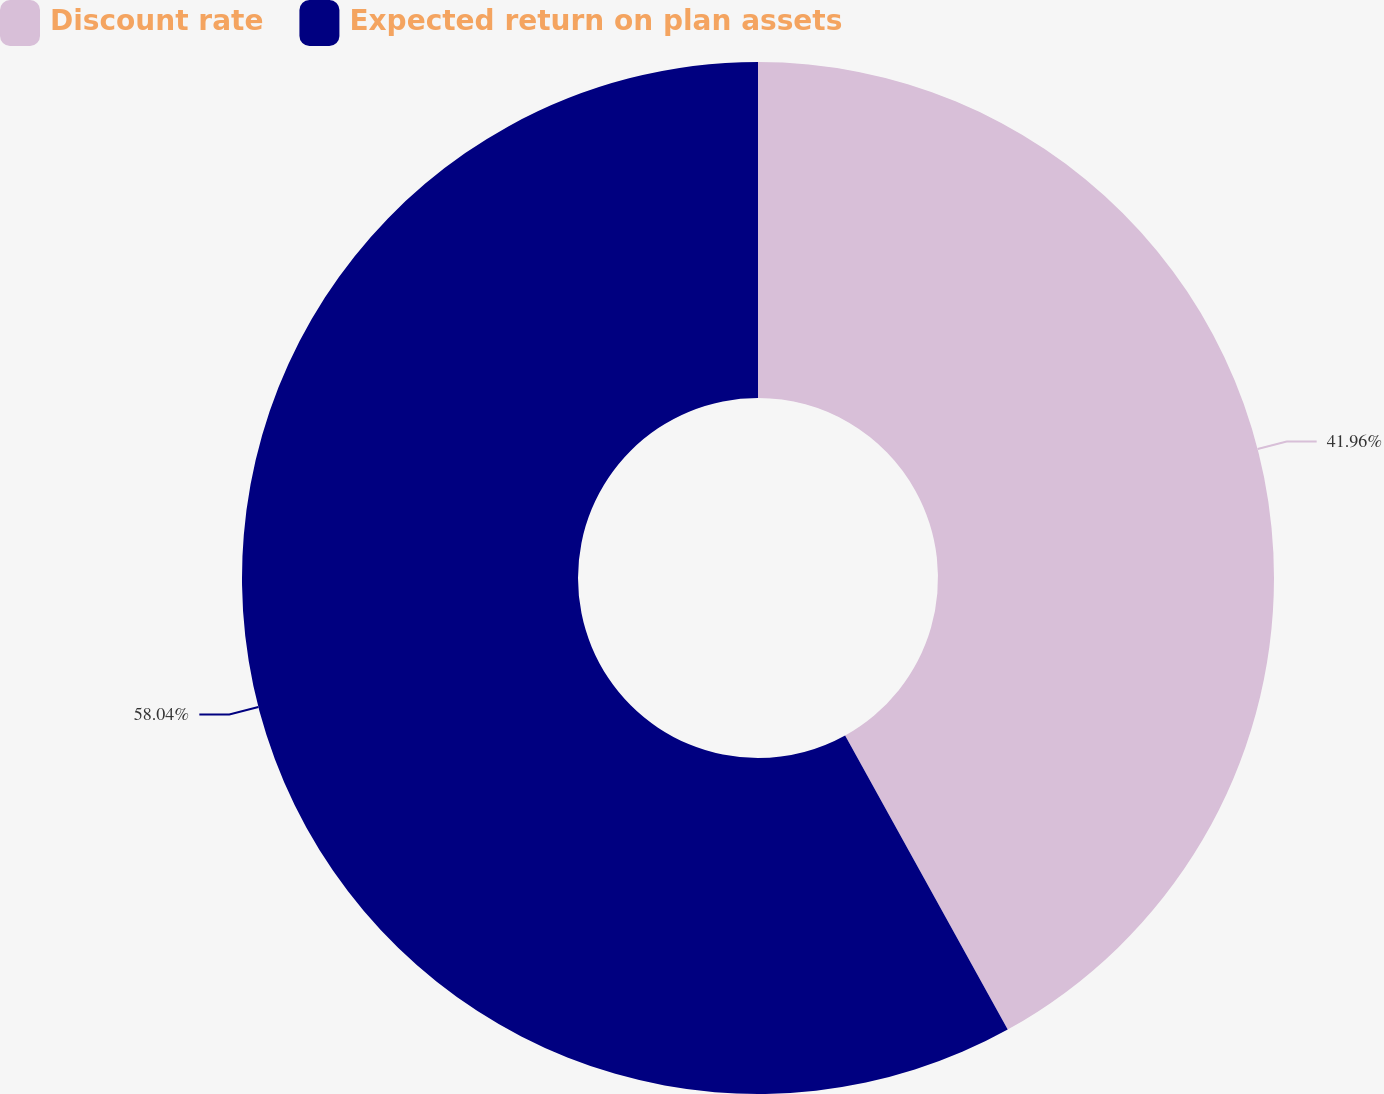Convert chart. <chart><loc_0><loc_0><loc_500><loc_500><pie_chart><fcel>Discount rate<fcel>Expected return on plan assets<nl><fcel>41.96%<fcel>58.04%<nl></chart> 